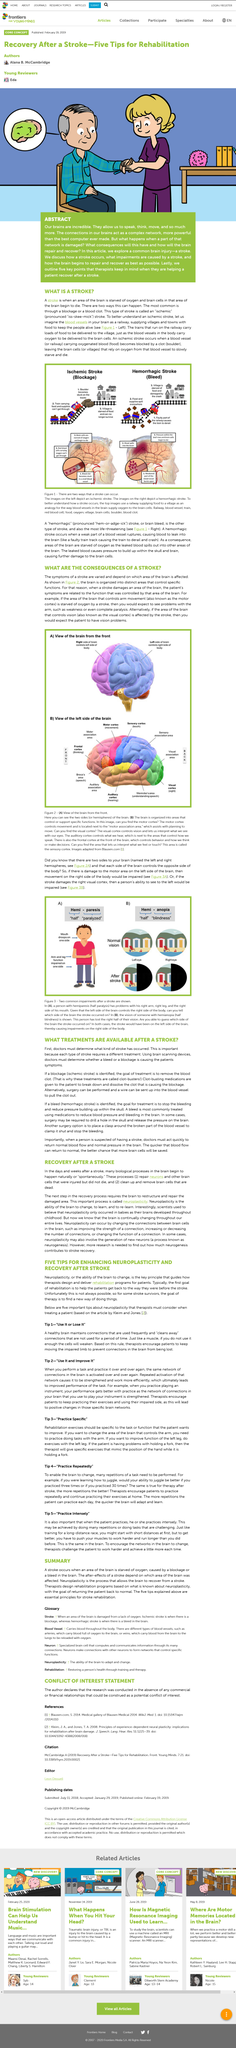Identify some key points in this picture. The article explores the effects of the most prevalent brain injury, which is a stroke. After an ischemic stroke, the available treatment is aimed at removing the blood clot that caused the stroke, in order to restore blood flow to the affected area of the brain. I am sorry, but the sentence you provided is not grammatically correct. It appears that you may have meant to ask "How many essential principles tips are explained? Five." However, this sentence is also not complete and does not convey a complete thought. Could you please provide more context or clarify your question? In a stroke, brain cells are deprived of oxygen, a critical component for their survival. The phrase "use it and improve it" means that the repeated use or completion of a muscle or task will inevitably lead to an improvement in the muscle or task over time, due to the brain creating positive changes in certain brain networks. 